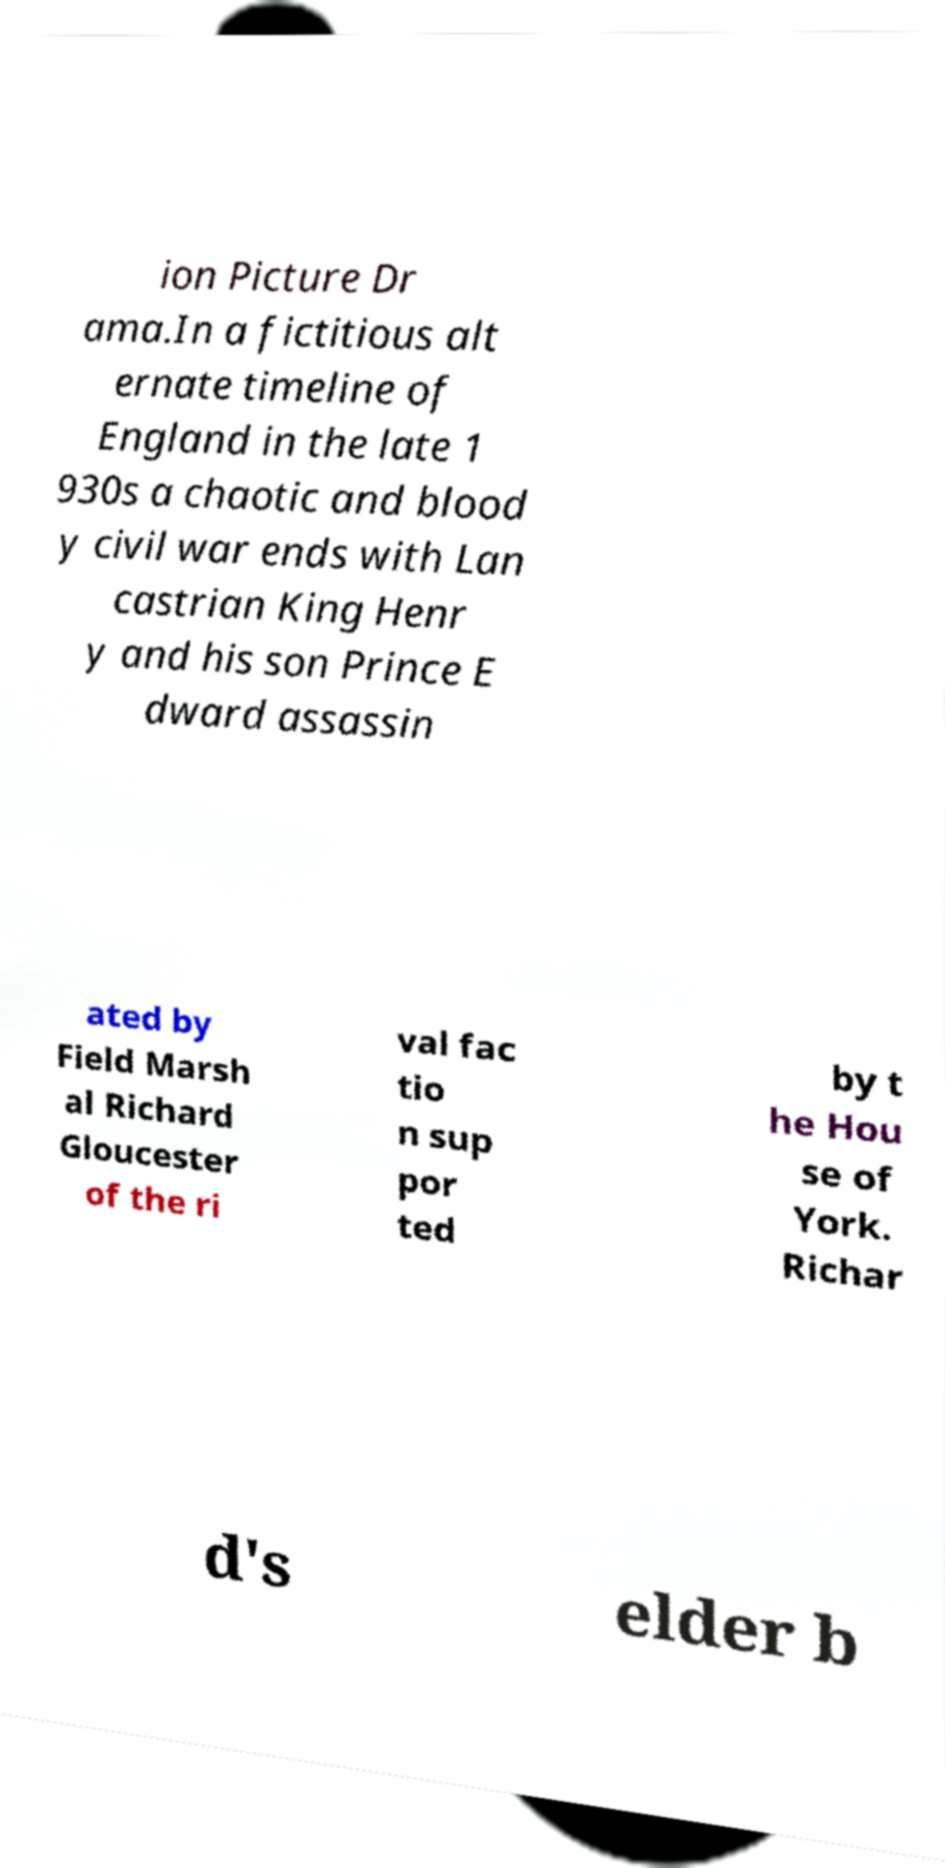Please identify and transcribe the text found in this image. ion Picture Dr ama.In a fictitious alt ernate timeline of England in the late 1 930s a chaotic and blood y civil war ends with Lan castrian King Henr y and his son Prince E dward assassin ated by Field Marsh al Richard Gloucester of the ri val fac tio n sup por ted by t he Hou se of York. Richar d's elder b 